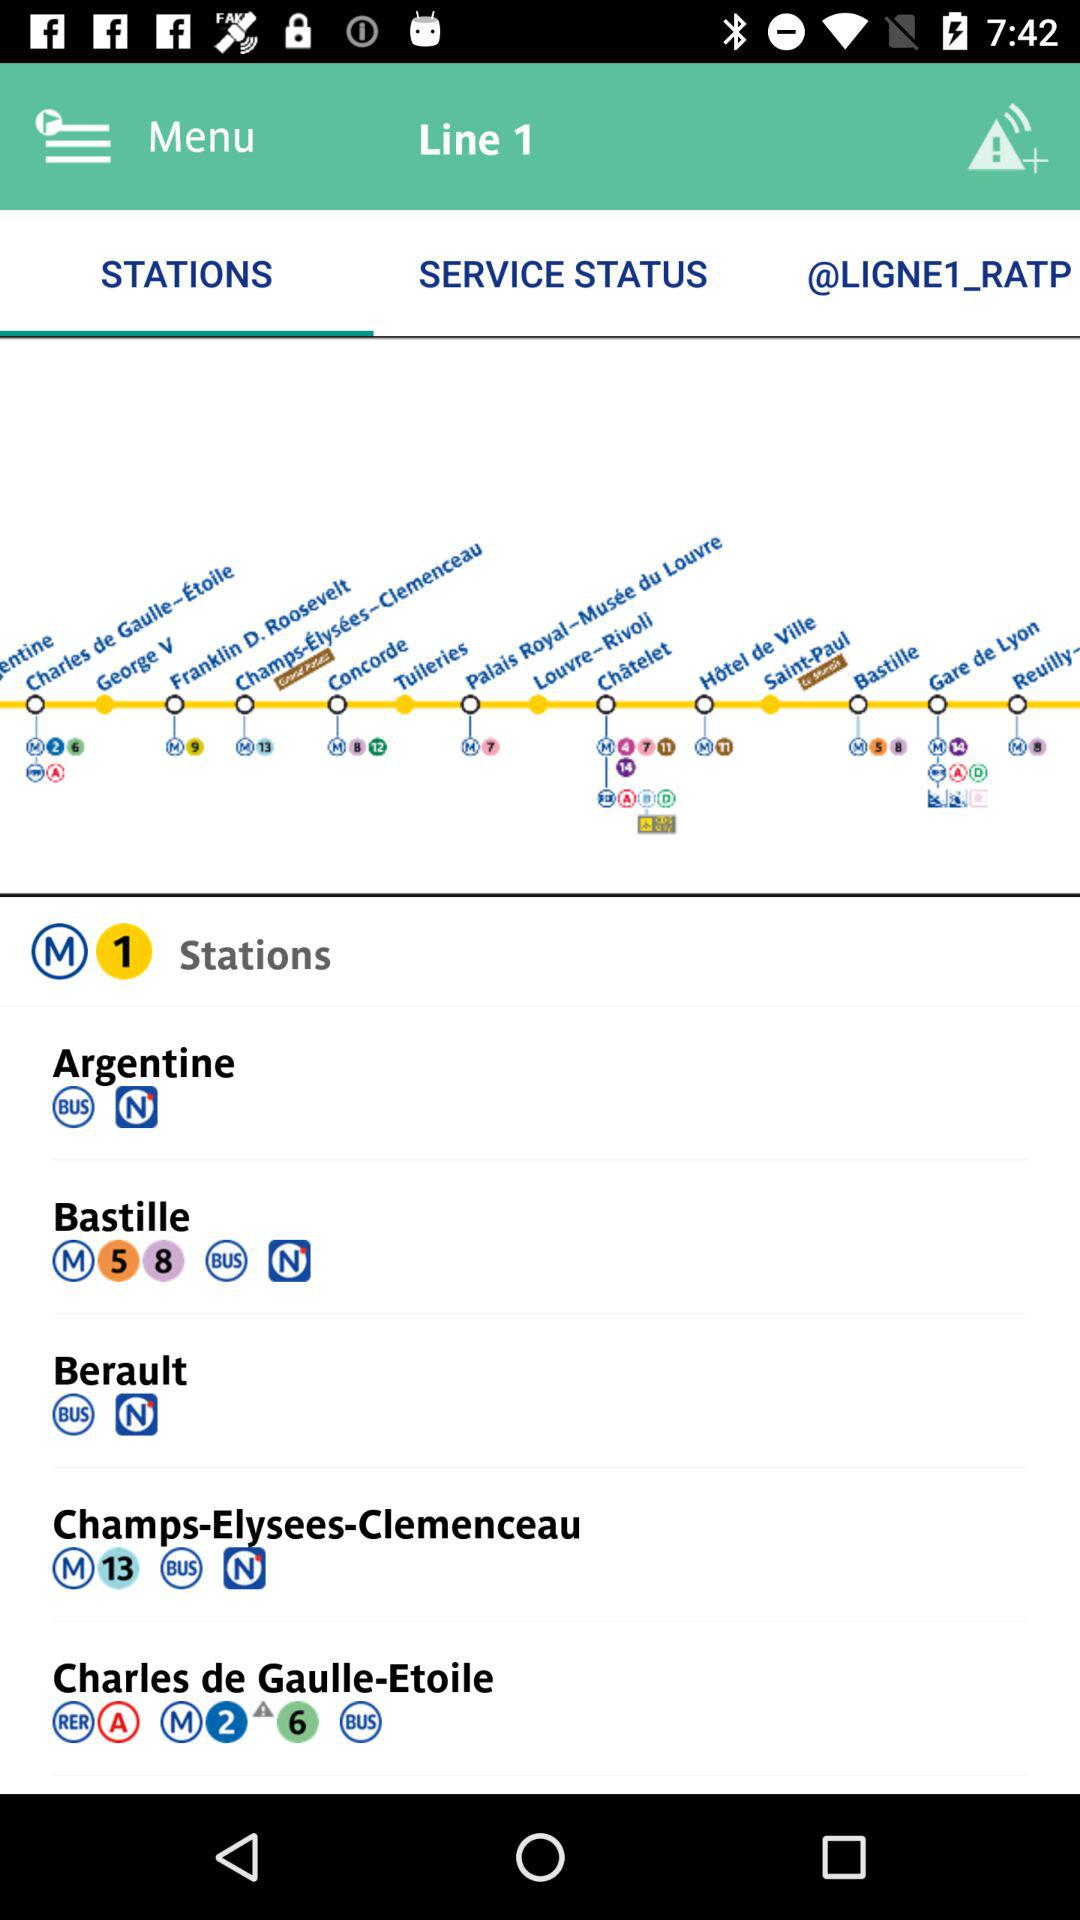How many stations are served by the RER line?
Answer the question using a single word or phrase. 1 